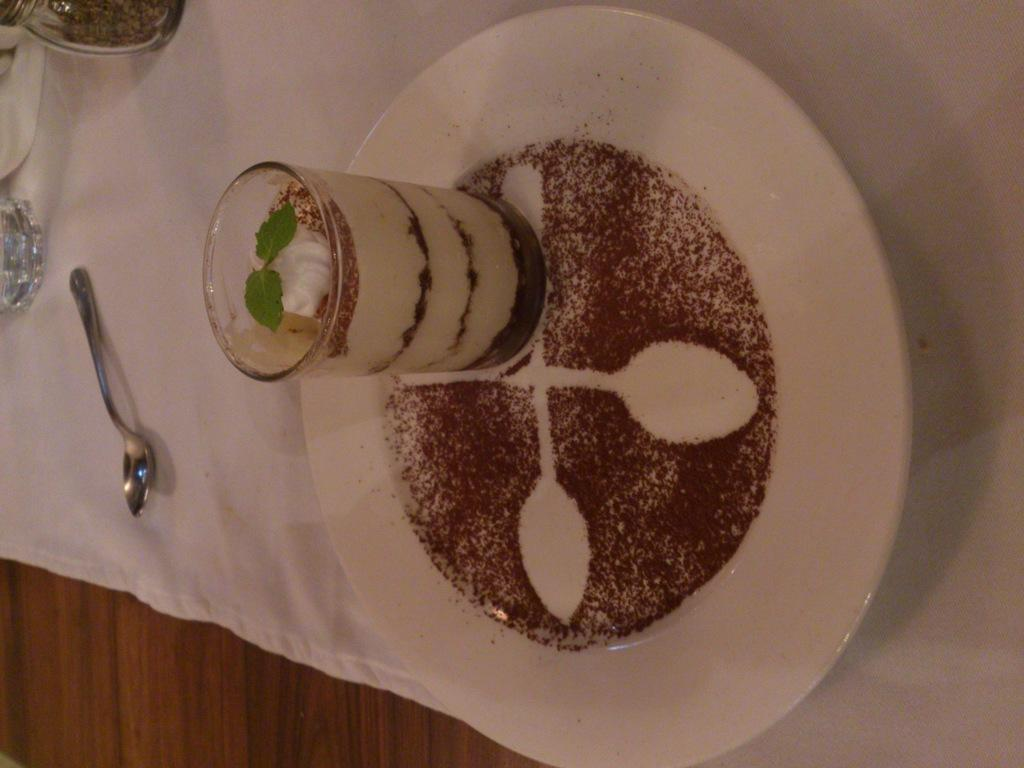What is the main subject in the image? There is an ice cream glass in the image. What is the ice cream glass placed on? The ice cream glass is on a white color plate. Where is the spoon located in the image? The spoon is on the left side of the image. What is the spoon placed on? The spoon is on a white color cloth. Can you see a hole in the ice cream glass in the image? No, there is no hole in the ice cream glass in the image. What type of pail is used to serve the ice cream in the image? There is no pail present in the image; it features an ice cream glass and a spoon. 